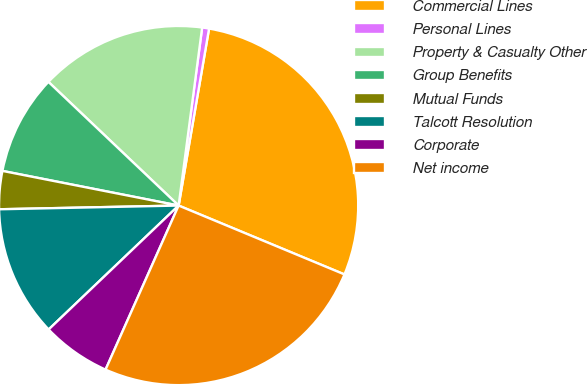Convert chart to OTSL. <chart><loc_0><loc_0><loc_500><loc_500><pie_chart><fcel>Commercial Lines<fcel>Personal Lines<fcel>Property & Casualty Other<fcel>Group Benefits<fcel>Mutual Funds<fcel>Talcott Resolution<fcel>Corporate<fcel>Net income<nl><fcel>28.55%<fcel>0.62%<fcel>15.0%<fcel>9.0%<fcel>3.42%<fcel>11.79%<fcel>6.21%<fcel>25.4%<nl></chart> 